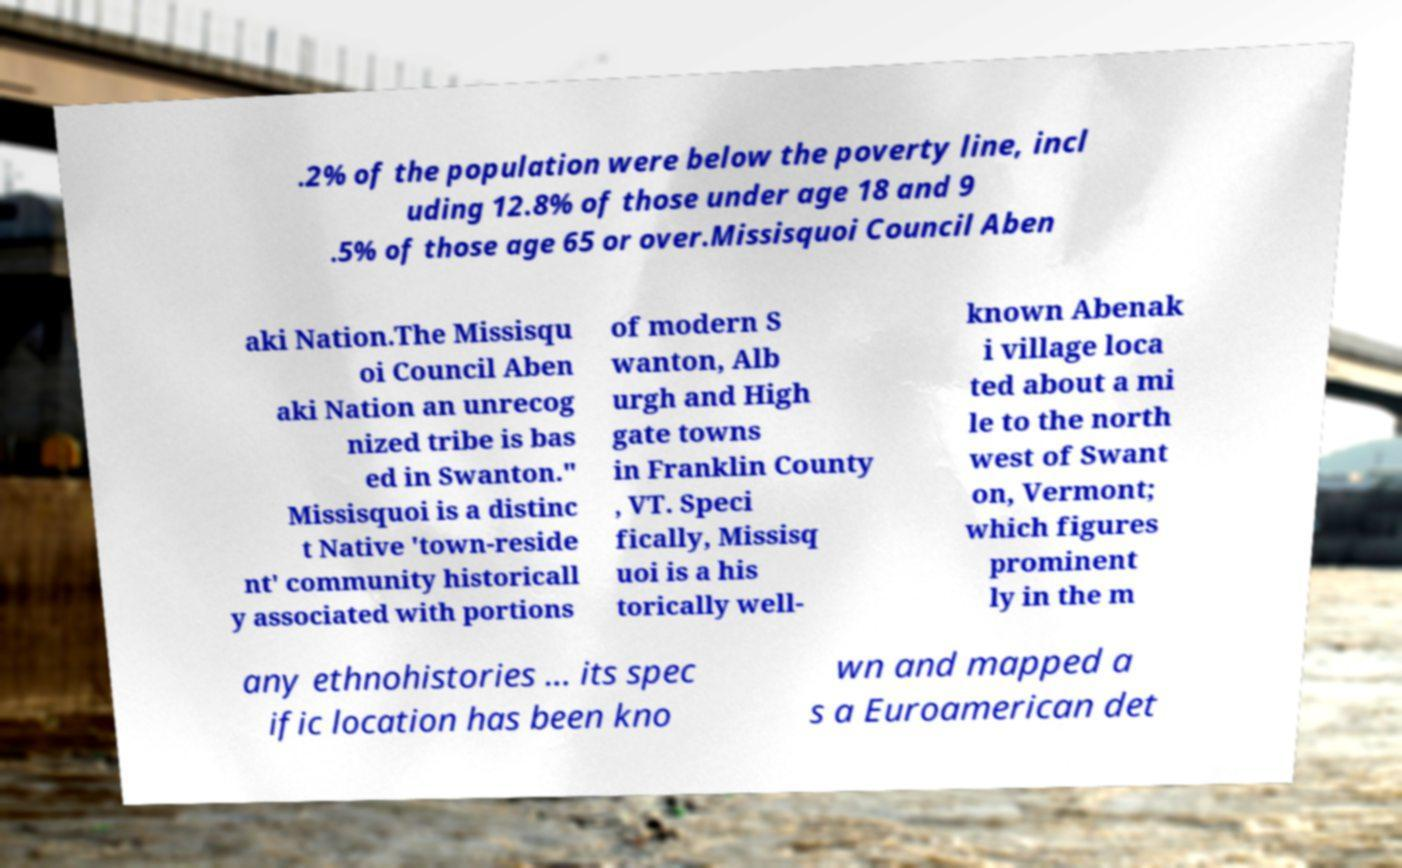Please read and relay the text visible in this image. What does it say? .2% of the population were below the poverty line, incl uding 12.8% of those under age 18 and 9 .5% of those age 65 or over.Missisquoi Council Aben aki Nation.The Missisqu oi Council Aben aki Nation an unrecog nized tribe is bas ed in Swanton." Missisquoi is a distinc t Native 'town-reside nt' community historicall y associated with portions of modern S wanton, Alb urgh and High gate towns in Franklin County , VT. Speci fically, Missisq uoi is a his torically well- known Abenak i village loca ted about a mi le to the north west of Swant on, Vermont; which figures prominent ly in the m any ethnohistories ... its spec ific location has been kno wn and mapped a s a Euroamerican det 